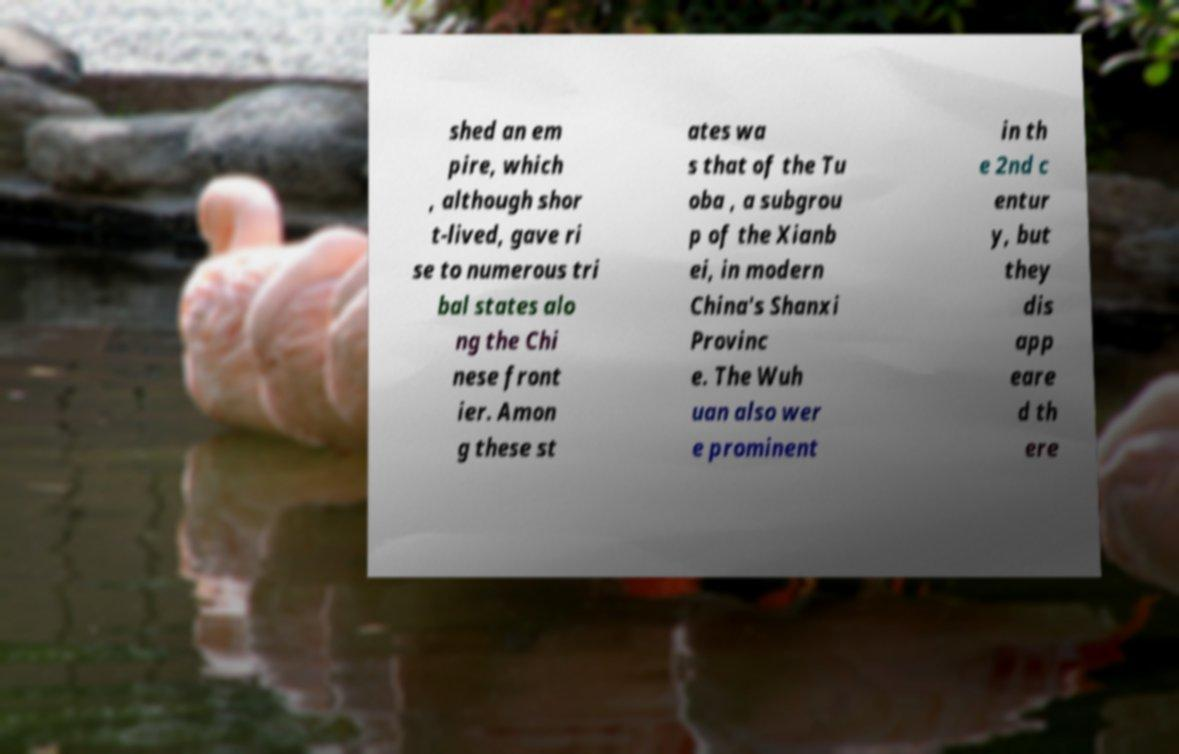For documentation purposes, I need the text within this image transcribed. Could you provide that? shed an em pire, which , although shor t-lived, gave ri se to numerous tri bal states alo ng the Chi nese front ier. Amon g these st ates wa s that of the Tu oba , a subgrou p of the Xianb ei, in modern China's Shanxi Provinc e. The Wuh uan also wer e prominent in th e 2nd c entur y, but they dis app eare d th ere 